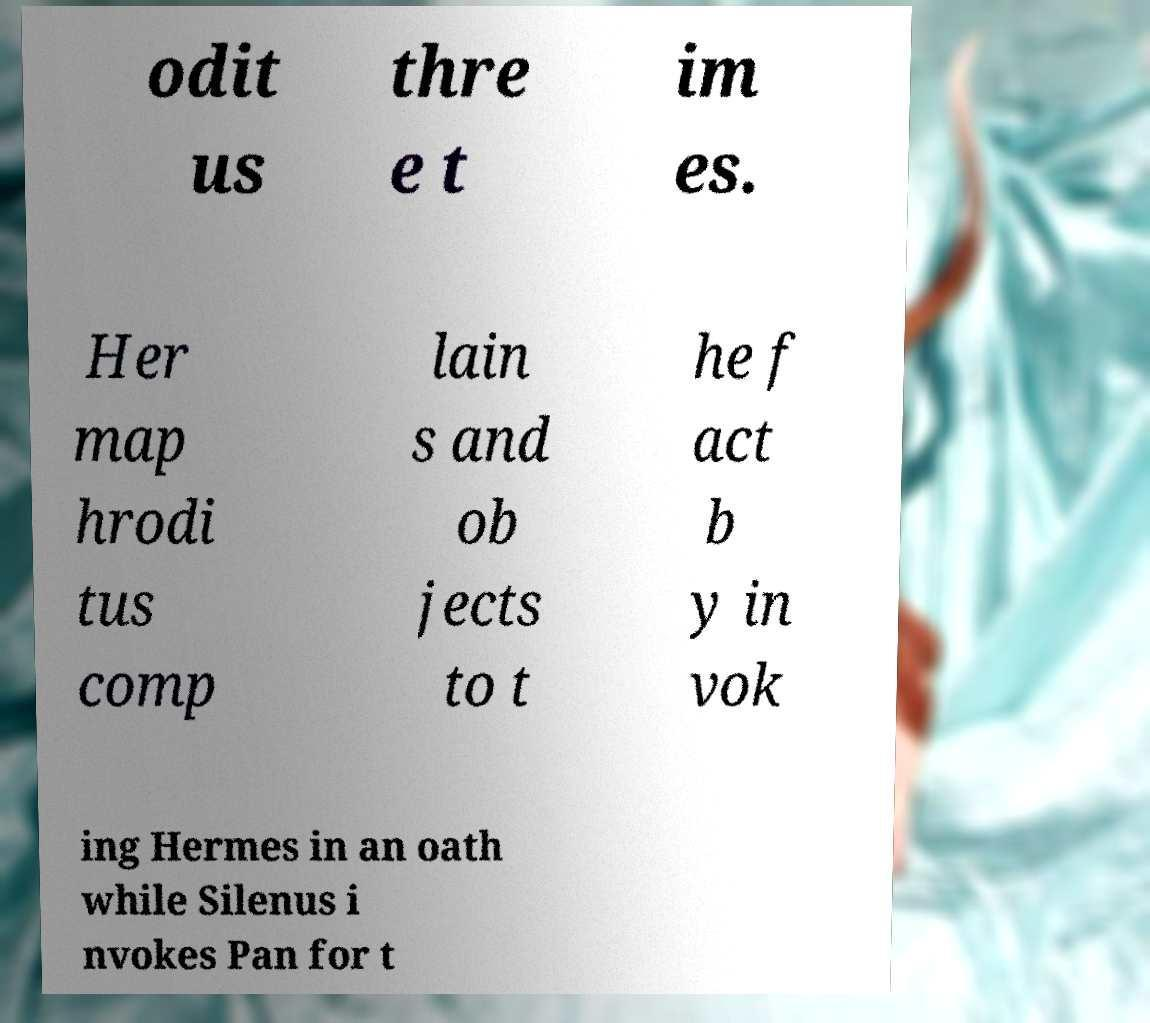What messages or text are displayed in this image? I need them in a readable, typed format. odit us thre e t im es. Her map hrodi tus comp lain s and ob jects to t he f act b y in vok ing Hermes in an oath while Silenus i nvokes Pan for t 